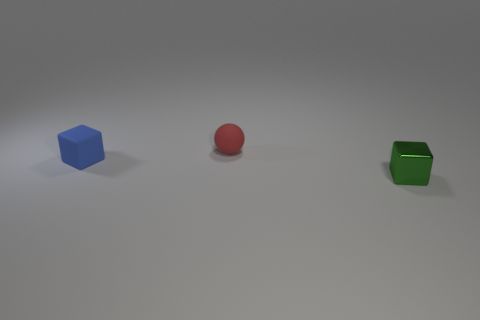There is a object that is both on the right side of the blue thing and behind the small green object; how big is it?
Ensure brevity in your answer.  Small. There is a matte object behind the small blue thing; is its shape the same as the tiny blue matte thing?
Offer a terse response. No. What is the size of the object on the right side of the rubber object that is behind the object on the left side of the tiny red rubber object?
Give a very brief answer. Small. What number of objects are either brown matte cylinders or red rubber things?
Provide a succinct answer. 1. What shape is the tiny thing that is both left of the tiny shiny cube and in front of the red matte thing?
Your response must be concise. Cube. Is the shape of the blue matte object the same as the thing on the right side of the red thing?
Offer a terse response. Yes. Are there any green things to the right of the small blue cube?
Offer a very short reply. Yes. How many spheres are small things or red things?
Your response must be concise. 1. Does the small metal object have the same shape as the small red rubber thing?
Offer a very short reply. No. What size is the block to the left of the small red object?
Make the answer very short. Small. 